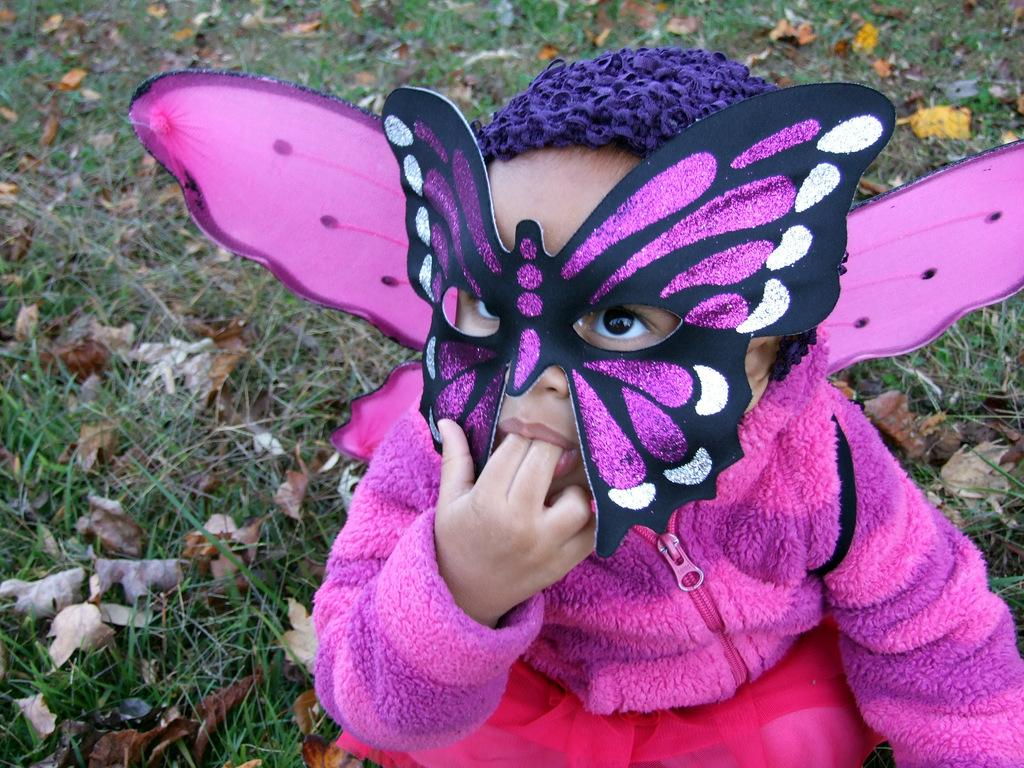What is the main subject of the image? There is a child in the image. What is the child wearing on their face? The child is wearing a mask. What type of surface is visible in the image? There is ground visible in the image. What kind of vegetation is present on the ground? Grass is present on the ground, and there are also dry leaves. How many people are in the crowd surrounding the child in the image? There is no crowd present in the image; it only features a child wearing a mask. What advice might the child's grandfather give them in the image? There is no grandfather present in the image, so it is not possible to determine what advice they might give. 